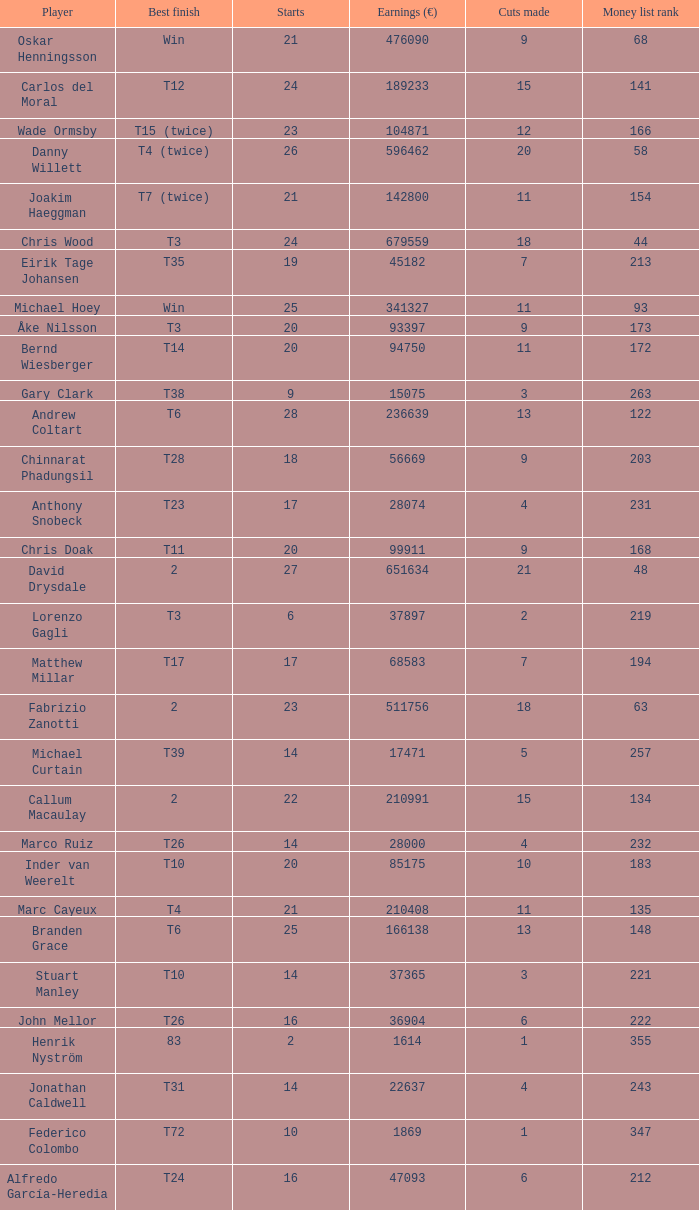How many cuts did Gary Clark make? 3.0. 